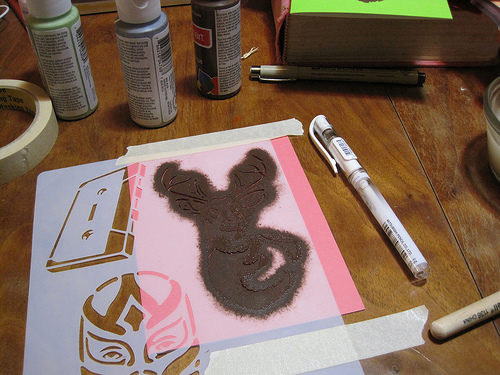<image>
Can you confirm if the pen is on the stencil? No. The pen is not positioned on the stencil. They may be near each other, but the pen is not supported by or resting on top of the stencil. Is there a paper to the right of the pen? No. The paper is not to the right of the pen. The horizontal positioning shows a different relationship. 